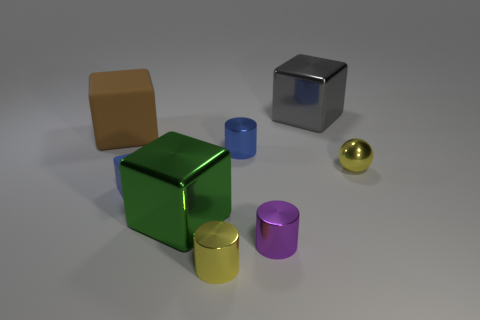Do the big rubber object and the large green shiny object have the same shape?
Your response must be concise. Yes. What number of objects are purple objects or tiny metal cylinders that are on the left side of the blue cylinder?
Make the answer very short. 2. How many small gray metallic cylinders are there?
Make the answer very short. 0. Are there any yellow things of the same size as the brown cube?
Provide a short and direct response. No. Are there fewer brown blocks that are in front of the tiny blue cube than large yellow metal objects?
Give a very brief answer. No. Does the gray cube have the same size as the blue metallic object?
Your response must be concise. No. What size is the blue object that is the same material as the brown cube?
Give a very brief answer. Small. How many tiny cylinders have the same color as the small cube?
Provide a short and direct response. 1. Are there fewer tiny yellow things on the left side of the small blue matte thing than big green metallic blocks that are to the right of the tiny yellow shiny sphere?
Provide a succinct answer. No. There is a yellow metal thing behind the big green metallic cube; is it the same shape as the green object?
Offer a terse response. No. 